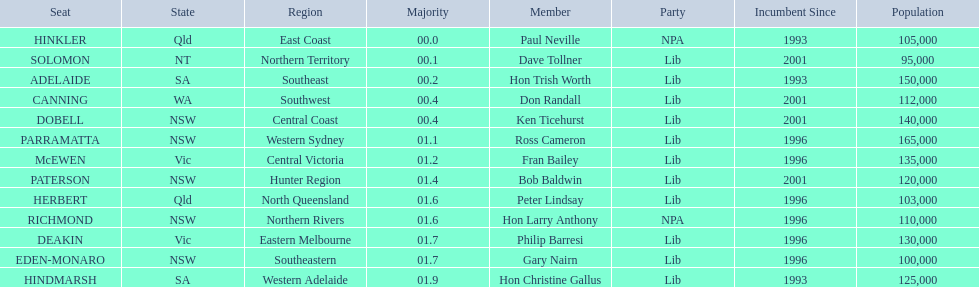Who are all the lib party members? Dave Tollner, Hon Trish Worth, Don Randall, Ken Ticehurst, Ross Cameron, Fran Bailey, Bob Baldwin, Peter Lindsay, Philip Barresi, Gary Nairn, Hon Christine Gallus. What lib party members are in sa? Hon Trish Worth, Hon Christine Gallus. What is the highest difference in majority between members in sa? 01.9. 